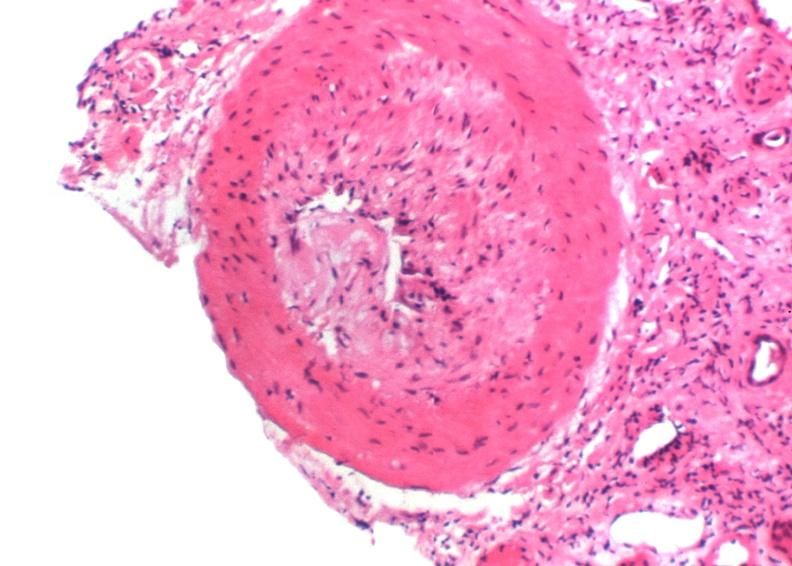does this image show kidney transplant rejection?
Answer the question using a single word or phrase. Yes 